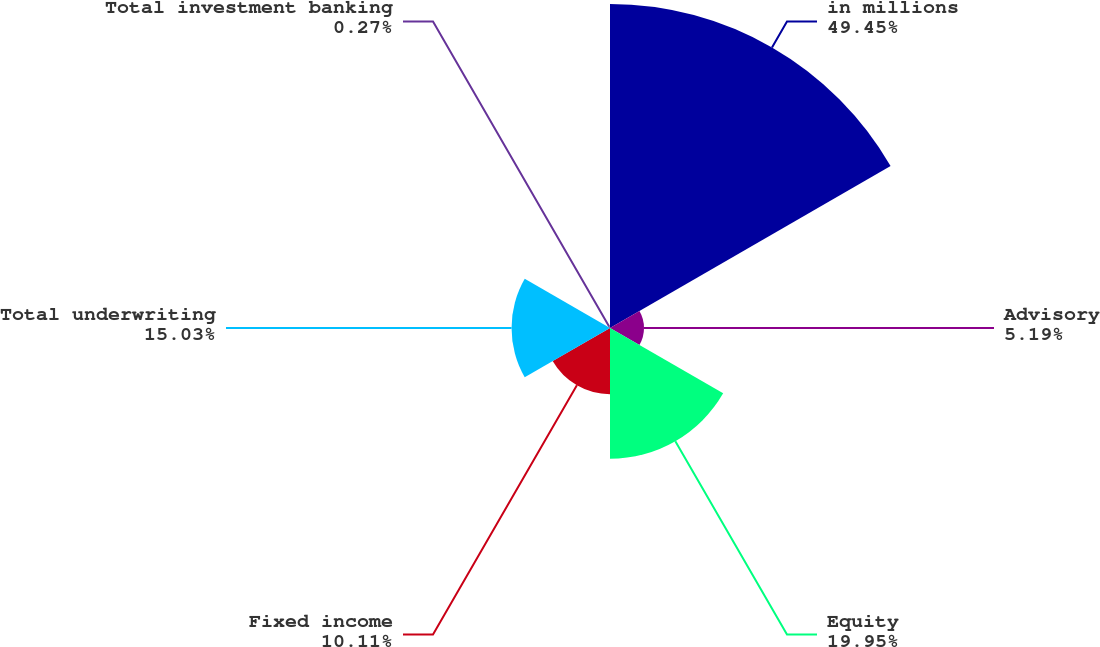<chart> <loc_0><loc_0><loc_500><loc_500><pie_chart><fcel>in millions<fcel>Advisory<fcel>Equity<fcel>Fixed income<fcel>Total underwriting<fcel>Total investment banking<nl><fcel>49.46%<fcel>5.19%<fcel>19.95%<fcel>10.11%<fcel>15.03%<fcel>0.27%<nl></chart> 